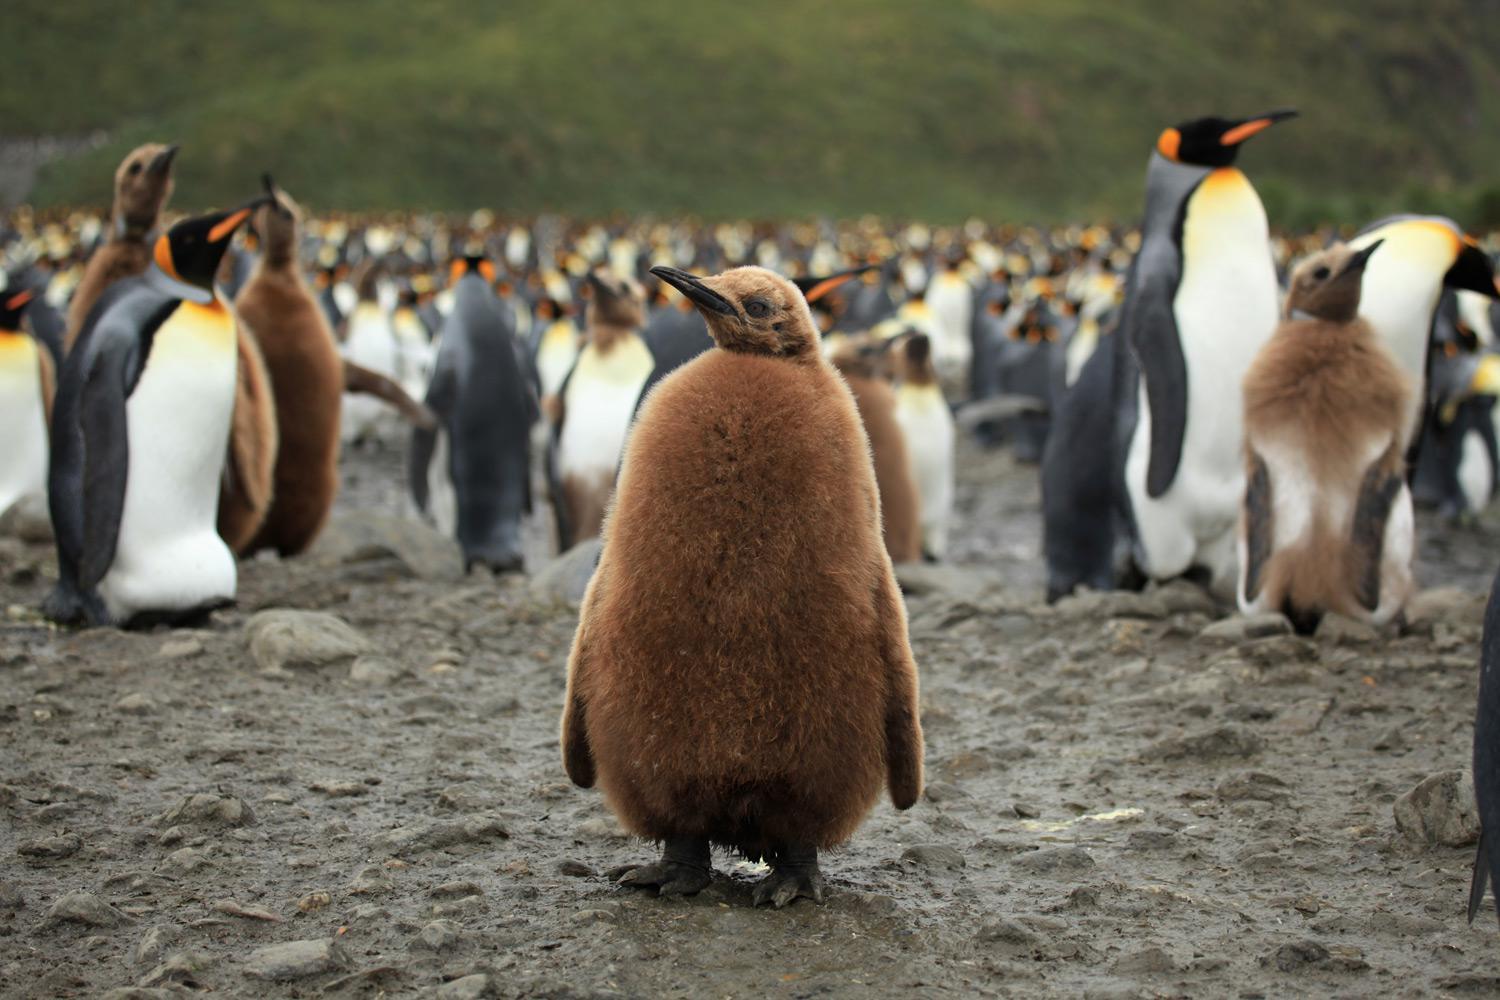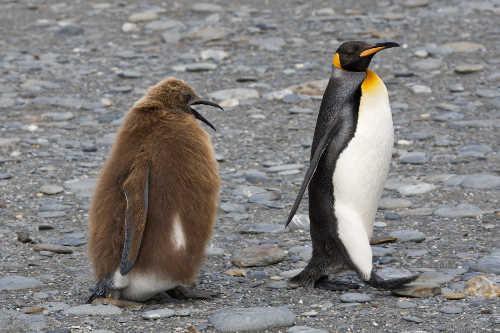The first image is the image on the left, the second image is the image on the right. Evaluate the accuracy of this statement regarding the images: "Just one black and white penguin is visible in one image.". Is it true? Answer yes or no. Yes. 